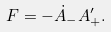<formula> <loc_0><loc_0><loc_500><loc_500>F = - \dot { A } _ { - } A ^ { \prime } _ { + } .</formula> 